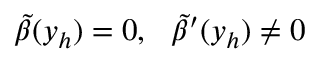<formula> <loc_0><loc_0><loc_500><loc_500>\tilde { \beta } ( y _ { h } ) = 0 , \quad t i l d e { \beta } ^ { \prime } ( y _ { h } ) \ne 0</formula> 